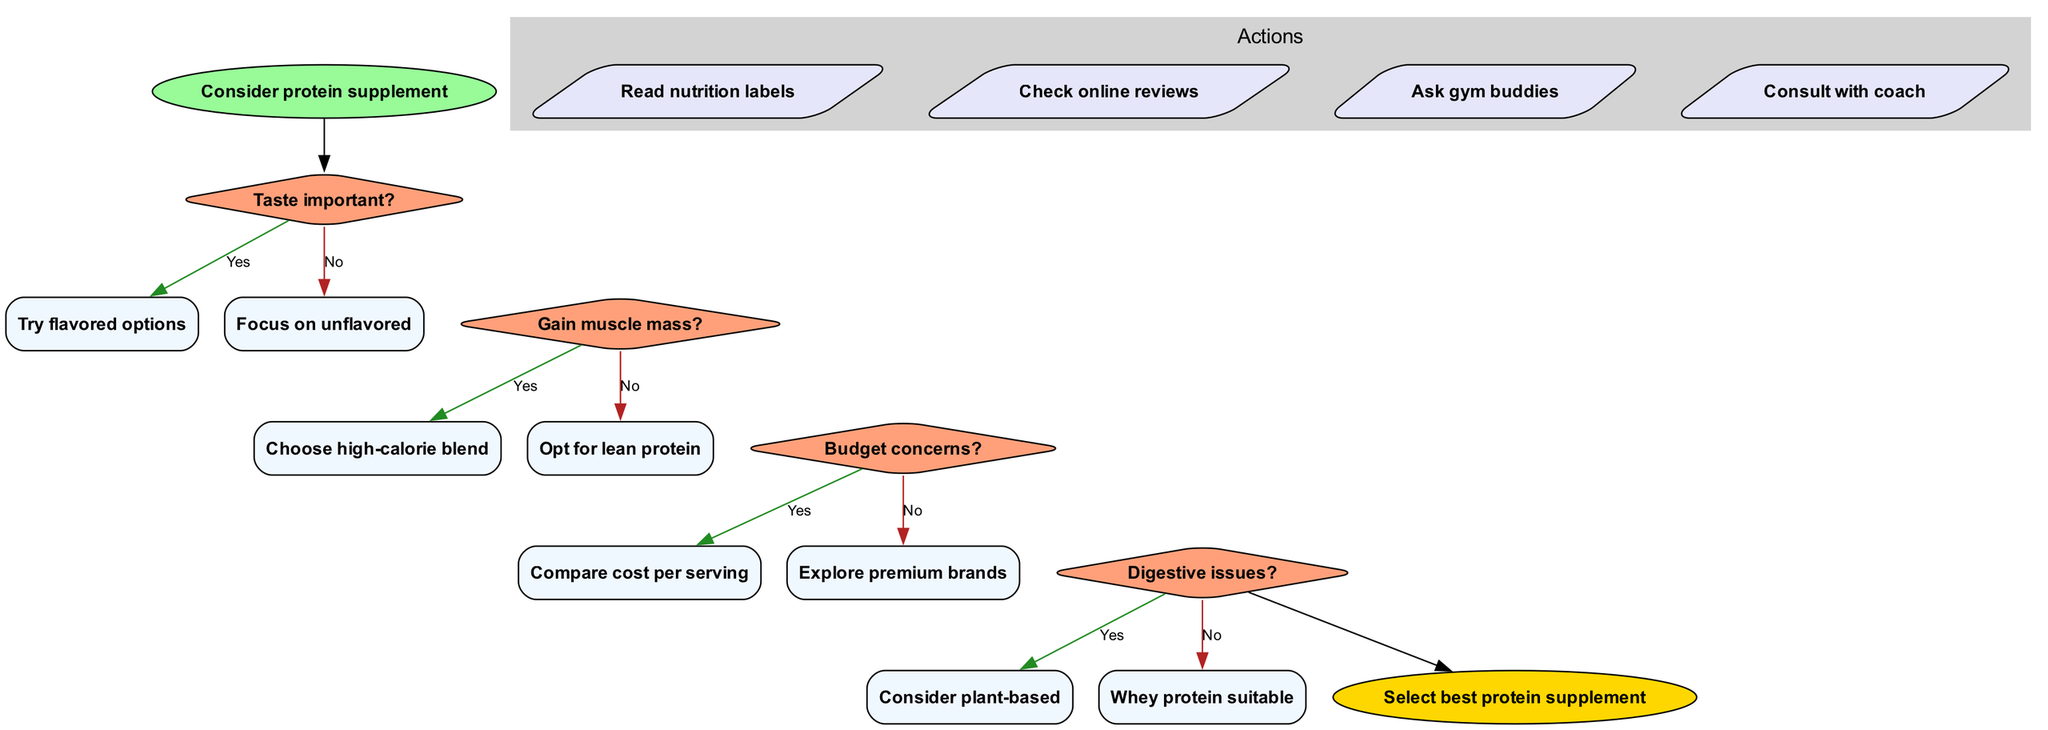What is the first question in the flowchart? The flowchart starts with the node labeled "Consider protein supplement," which leads to the first decision question asking if "Taste important?".
Answer: Taste important? How many action nodes are there in the diagram? In the diagram, there is a cluster labeled "Actions" which contains four action nodes. Each action is presented as a parallelogram, making a total of four actions.
Answer: 4 What happens if the answer to "Gain muscle mass?" is no? If the answer to "Gain muscle mass?" is no, the flow directs to the next decision point, which advises to "Opt for lean protein." This is the response for the "No" option of that decision question.
Answer: Opt for lean protein Which protein type is suggested for those with digestive issues? The flowchart indicates that if the answer to "Digestive issues?" is yes, the diagram suggests "Consider plant-based," pointing to a plant-based protein option as the resolution for that concern.
Answer: Consider plant-based What is the final action to take after completing the decisions? After navigating through all decisions in the flowchart, the last node leads to an end node labeled "Select best protein supplement," indicating the final action to take based on earlier choices.
Answer: Select best protein supplement If someone has budget concerns, what is the recommended step? When the decision for "Budget concerns?" is affirmed as yes, the flowchart indicates to "Compare cost per serving," which directs the user to consider the costs associated with the protein supplements.
Answer: Compare cost per serving What is the color of the start node? The start node, titled "Consider protein supplement," is filled with the color green, specifically a shade that is denoted by the hex color code #98FB98 in the diagram.
Answer: Green If someone answers "Yes" to all decision questions, what type of protein will they choose? By following a "Yes" answer through each question sequentially leads to eventually opting for a "Choose high-calorie blend," indicating this as the route selected if all decisions lean towards 'yes.'
Answer: Choose high-calorie blend What shape represents the decision nodes in the diagram? The diagram employs a diamond shape for the decision nodes; this shape is typical for decision-making processes and distinctively marks all such questions in the flow.
Answer: Diamond 